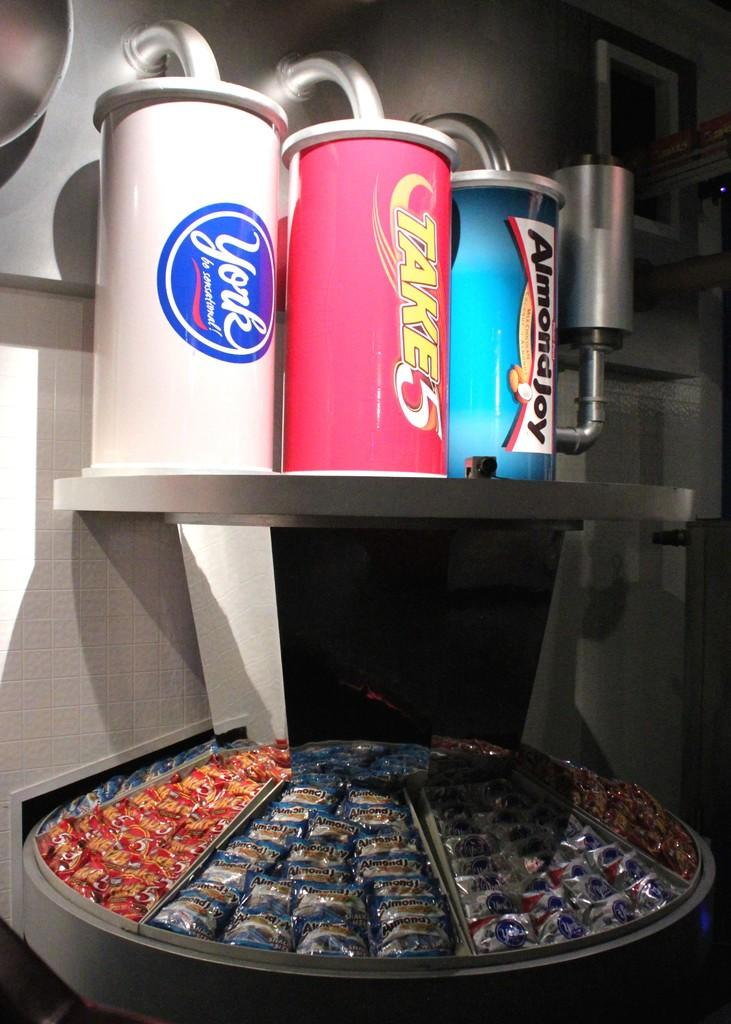<image>
Give a short and clear explanation of the subsequent image. The large cylinders above the round tray display have different candy flavors on them, such as Almond Joy. 